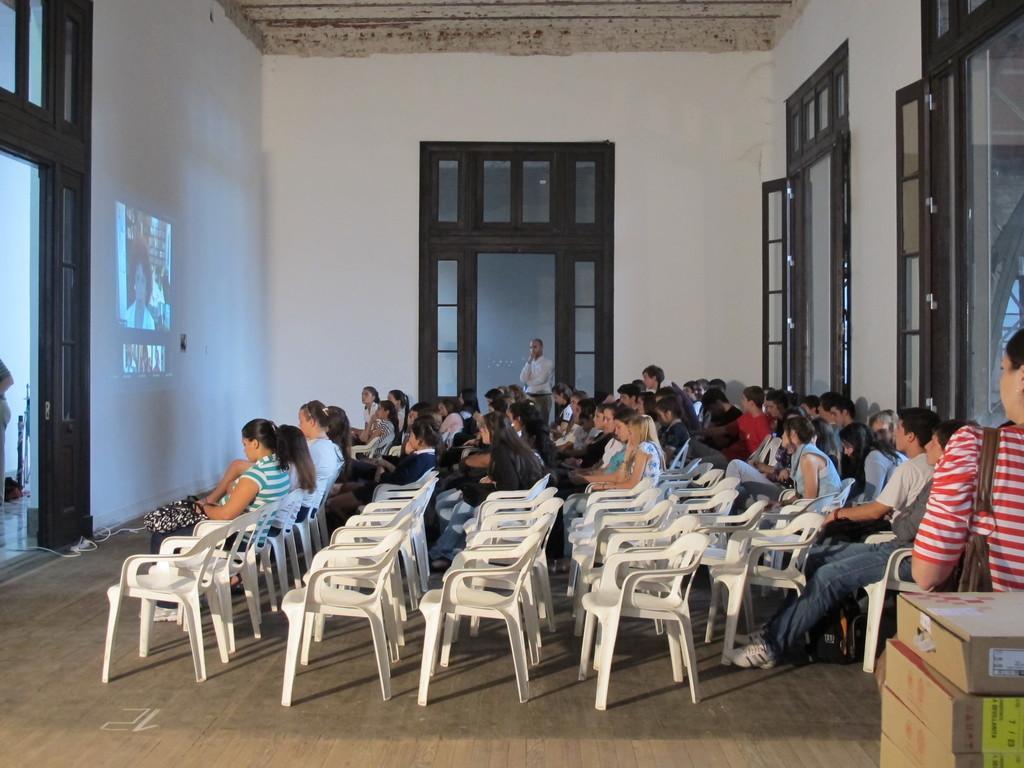Could you give a brief overview of what you see in this image? In this image I can see group of people sitting on the chairs. In front of them there is a projector to the wall. At the right I can see a woman holding the bag. At the backside of woman there are some cardboard boxes. 